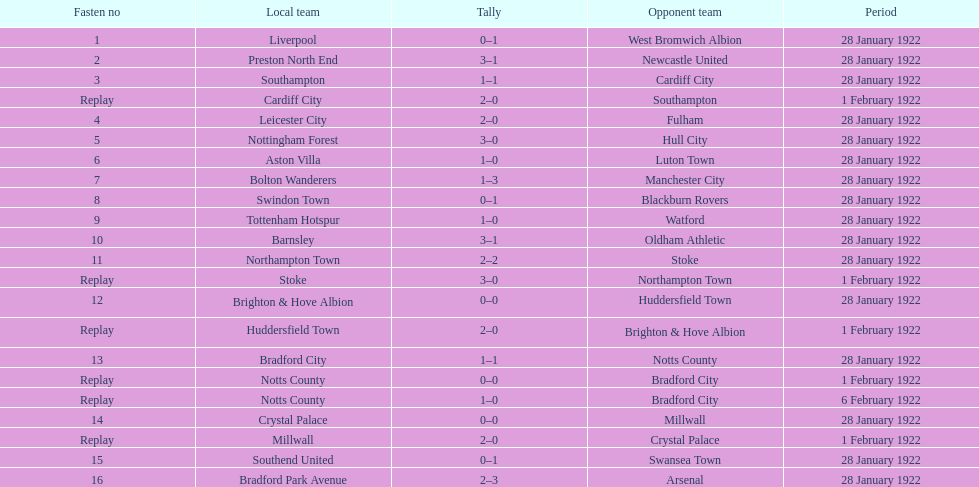What home team had the same score as aston villa on january 28th, 1922? Tottenham Hotspur. 